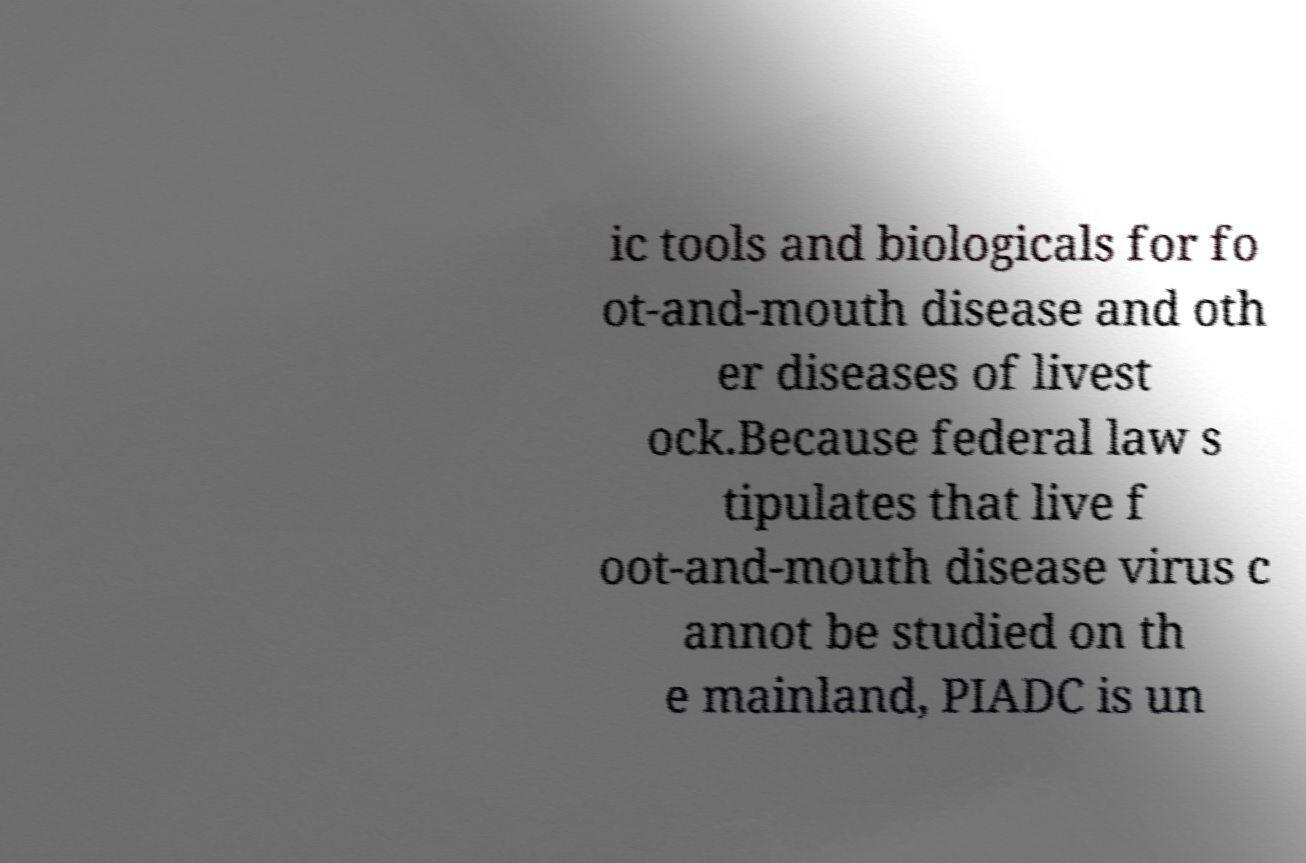Please identify and transcribe the text found in this image. ic tools and biologicals for fo ot-and-mouth disease and oth er diseases of livest ock.Because federal law s tipulates that live f oot-and-mouth disease virus c annot be studied on th e mainland, PIADC is un 